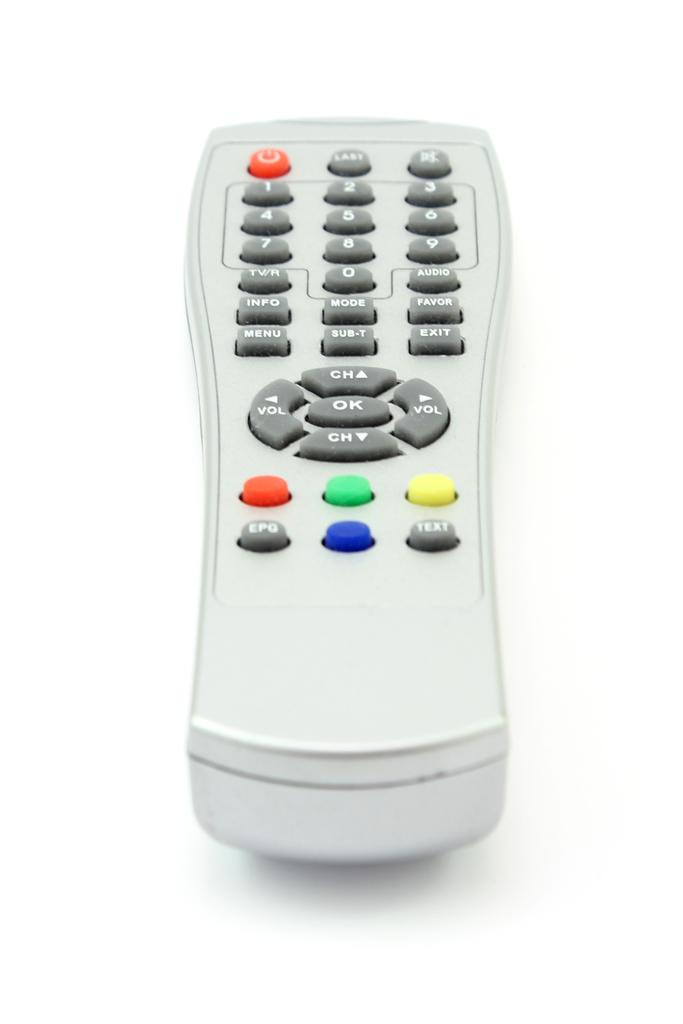<image>
Create a compact narrative representing the image presented. A simple, light colored, universal remote control has four unmarked, colorful buttons while the others labeled for volume, channel, and the numbers are grey buttons. 